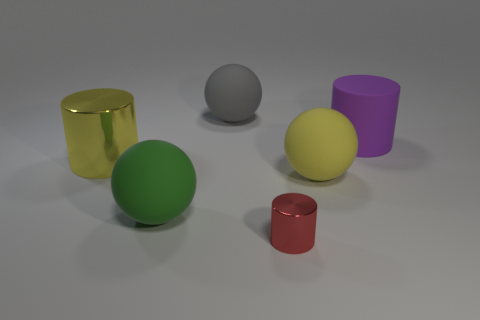Subtract all large cylinders. How many cylinders are left? 1 Subtract 1 cylinders. How many cylinders are left? 2 Add 1 purple balls. How many objects exist? 7 Subtract all small cyan cylinders. Subtract all tiny red cylinders. How many objects are left? 5 Add 3 big purple rubber things. How many big purple rubber things are left? 4 Add 3 purple cylinders. How many purple cylinders exist? 4 Subtract 0 red spheres. How many objects are left? 6 